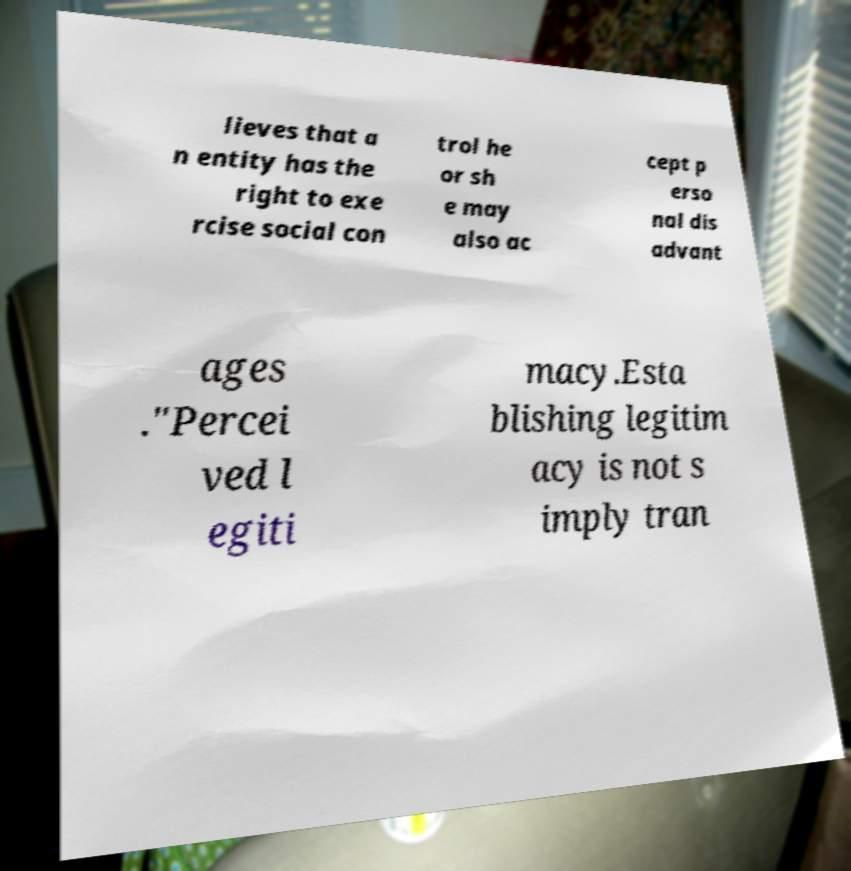For documentation purposes, I need the text within this image transcribed. Could you provide that? lieves that a n entity has the right to exe rcise social con trol he or sh e may also ac cept p erso nal dis advant ages ."Percei ved l egiti macy.Esta blishing legitim acy is not s imply tran 